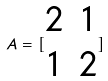Convert formula to latex. <formula><loc_0><loc_0><loc_500><loc_500>A = [ \begin{matrix} 2 & 1 \\ 1 & 2 \end{matrix} ]</formula> 